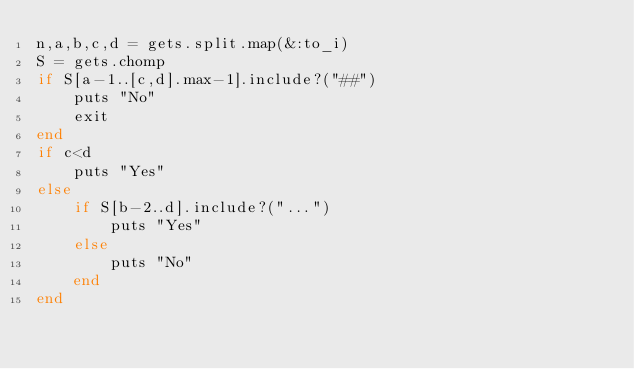<code> <loc_0><loc_0><loc_500><loc_500><_Ruby_>n,a,b,c,d = gets.split.map(&:to_i)
S = gets.chomp
if S[a-1..[c,d].max-1].include?("##")
    puts "No"
    exit
end
if c<d
    puts "Yes"
else
    if S[b-2..d].include?("...")
        puts "Yes"
    else
        puts "No"
    end
end</code> 